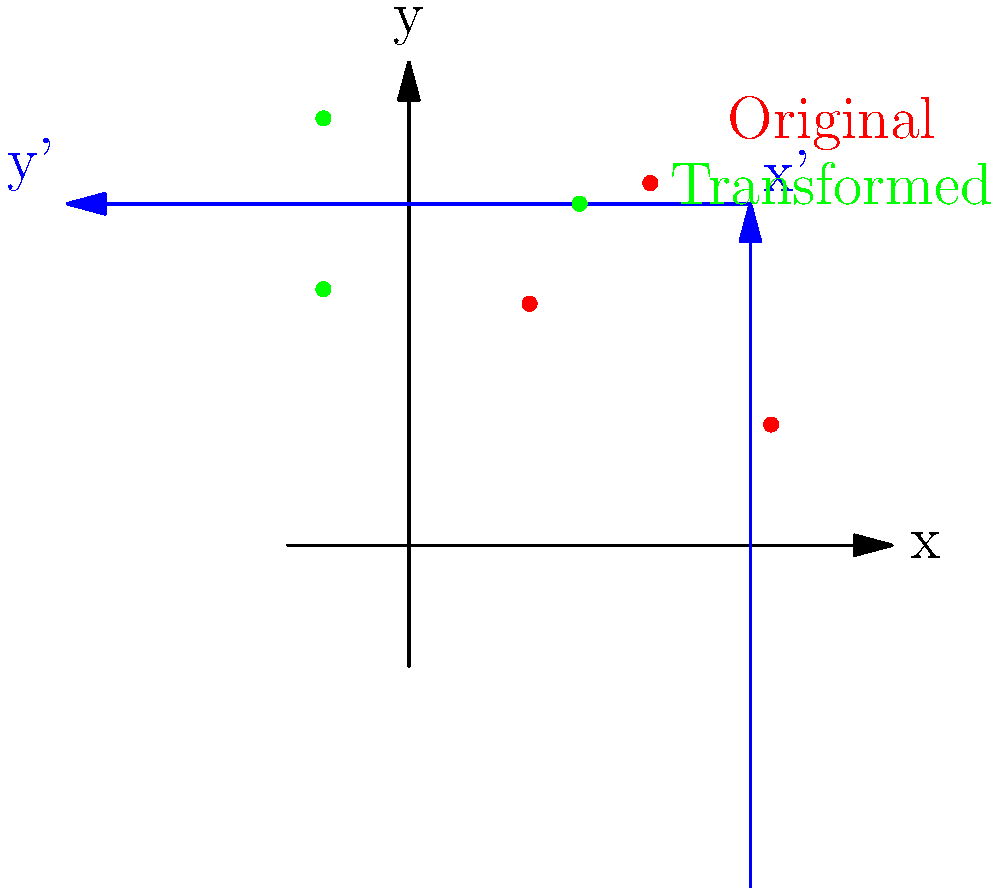In your latest digital art project, you're creating a galactic scene where star clusters are represented as points in a 2D coordinate system. You decide to apply a rotation transformation to these clusters to create a swirling effect. Given the rotation matrix $R = \begin{bmatrix} \cos(\frac{\pi}{4}) & -\sin(\frac{\pi}{4}) \\ \sin(\frac{\pi}{4}) & \cos(\frac{\pi}{4}) \end{bmatrix}$, which represents a counterclockwise rotation by 45°, and the original coordinates of a star cluster $(3,1)$, what are the new coordinates of this cluster after the transformation? To find the new coordinates of the star cluster after the rotation transformation, we need to multiply the rotation matrix by the original coordinates vector. Let's break this down step-by-step:

1) The rotation matrix $R$ is given as:
   $R = \begin{bmatrix} \cos(\frac{\pi}{4}) & -\sin(\frac{\pi}{4}) \\ \sin(\frac{\pi}{4}) & \cos(\frac{\pi}{4}) \end{bmatrix}$

2) The original coordinates are $(3,1)$, which we can represent as a column vector:
   $\begin{bmatrix} 3 \\ 1 \end{bmatrix}$

3) To apply the transformation, we multiply the rotation matrix by the coordinates vector:
   $\begin{bmatrix} \cos(\frac{\pi}{4}) & -\sin(\frac{\pi}{4}) \\ \sin(\frac{\pi}{4}) & \cos(\frac{\pi}{4}) \end{bmatrix} \begin{bmatrix} 3 \\ 1 \end{bmatrix}$

4) Perform the matrix multiplication:
   $\begin{bmatrix} 3\cos(\frac{\pi}{4}) - \sin(\frac{\pi}{4}) \\ 3\sin(\frac{\pi}{4}) + \cos(\frac{\pi}{4}) \end{bmatrix}$

5) Recall that $\cos(\frac{\pi}{4}) = \sin(\frac{\pi}{4}) = \frac{\sqrt{2}}{2}$. Substituting these values:
   $\begin{bmatrix} 3(\frac{\sqrt{2}}{2}) - \frac{\sqrt{2}}{2} \\ 3(\frac{\sqrt{2}}{2}) + \frac{\sqrt{2}}{2} \end{bmatrix}$

6) Simplify:
   $\begin{bmatrix} \frac{3\sqrt{2}}{2} - \frac{\sqrt{2}}{2} \\ \frac{3\sqrt{2}}{2} + \frac{\sqrt{2}}{2} \end{bmatrix} = \begin{bmatrix} \sqrt{2} \\ 2\sqrt{2} \end{bmatrix}$

Therefore, the new coordinates of the star cluster after the rotation transformation are $(\sqrt{2}, 2\sqrt{2})$.
Answer: $(\sqrt{2}, 2\sqrt{2})$ 